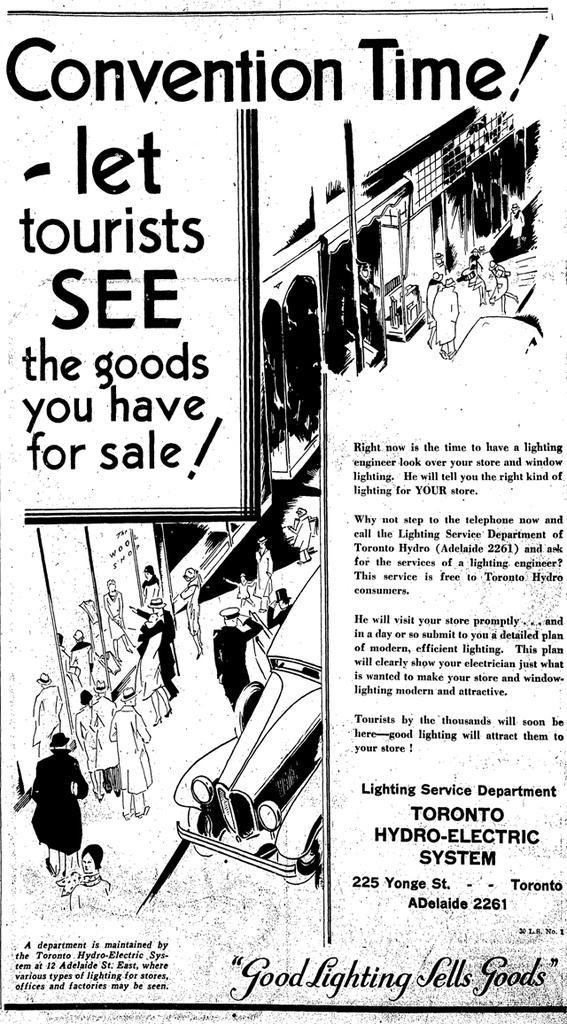In one or two sentences, can you explain what this image depicts? In this picture, we can see a poster with some text and some images on it. 